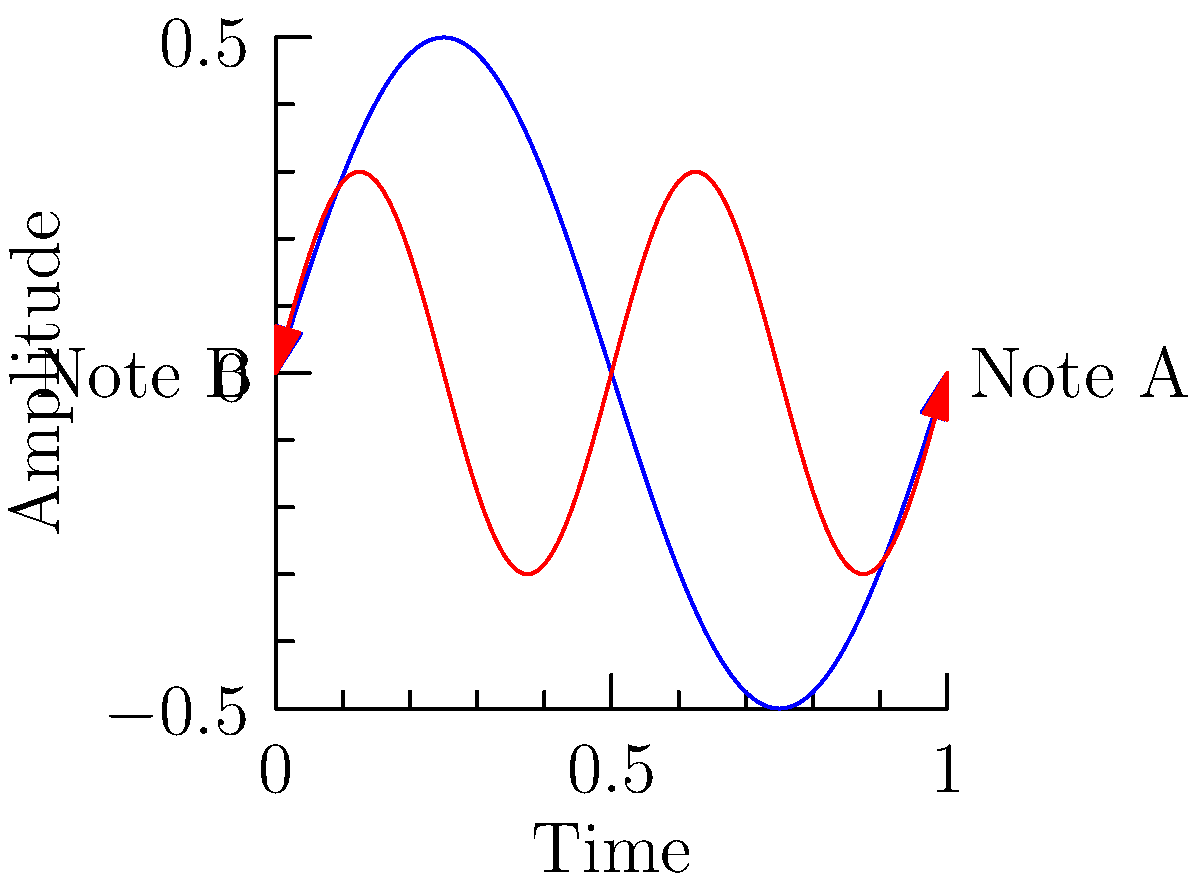As a jazz saxophonist, you're analyzing the sound waves of two different notes you've played. The blue curve represents Note A with amplitude 0.5 and frequency 1 Hz, while the red curve represents Note B with amplitude 0.3 and frequency 2 Hz. Both waves can be represented as vectors in the form $\vec{v} = (A \cos \theta, A \sin \theta)$, where $A$ is the amplitude and $\theta = 2\pi ft$ (with $f$ being the frequency and $t$ the time). At $t = 0.25$ seconds, what is the magnitude of the resultant vector when these two sound waves are combined? Let's approach this step-by-step:

1) For Note A: $f_A = 1$ Hz, $A_A = 0.5$
   For Note B: $f_B = 2$ Hz, $A_B = 0.3$

2) At $t = 0.25$ seconds:
   For Note A: $\theta_A = 2\pi f_A t = 2\pi(1)(0.25) = \frac{\pi}{2}$
   For Note B: $\theta_B = 2\pi f_B t = 2\pi(2)(0.25) = \pi$

3) Vector for Note A:
   $\vec{v_A} = (0.5 \cos \frac{\pi}{2}, 0.5 \sin \frac{\pi}{2}) = (0, 0.5)$

4) Vector for Note B:
   $\vec{v_B} = (0.3 \cos \pi, 0.3 \sin \pi) = (-0.3, 0)$

5) The resultant vector is the sum of these two vectors:
   $\vec{v_R} = \vec{v_A} + \vec{v_B} = (0, 0.5) + (-0.3, 0) = (-0.3, 0.5)$

6) The magnitude of the resultant vector is:
   $|\vec{v_R}| = \sqrt{(-0.3)^2 + (0.5)^2} = \sqrt{0.09 + 0.25} = \sqrt{0.34} \approx 0.5831$
Answer: $0.5831$ 